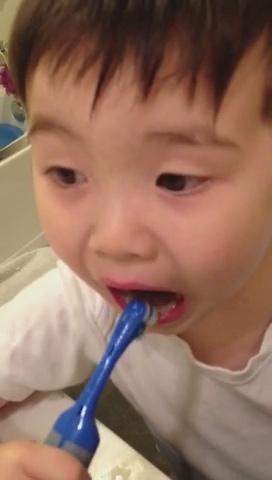What color are the baby's eyes?
Be succinct. Brown. What color are the child's eyes?
Concise answer only. Brown. Is this a child of European descent?
Concise answer only. No. Is the child's hair blonde?
Write a very short answer. No. What color is the toothbrush?
Write a very short answer. Blue. What is the baby chewing?
Give a very brief answer. Toothbrush. What is the child doing?
Quick response, please. Brushing teeth. Is the kid talking on the phone?
Keep it brief. No. 